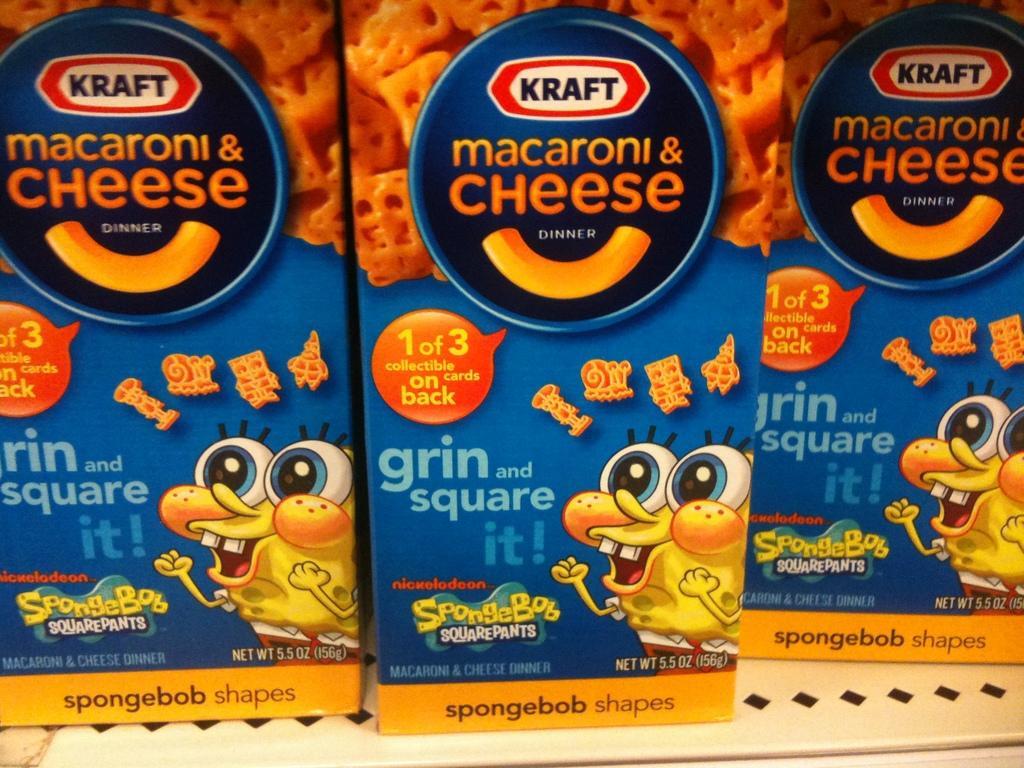Please provide a concise description of this image. In this picture we can see three cheese boxes here, we can see depictions on these boxes. 